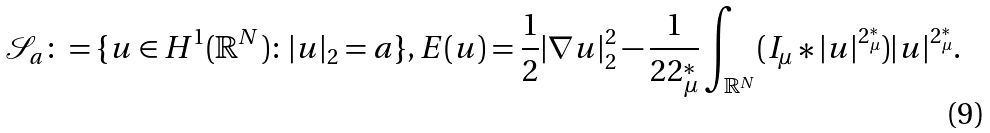Convert formula to latex. <formula><loc_0><loc_0><loc_500><loc_500>\mathcal { S } _ { a } \colon = \{ u \in H ^ { 1 } ( \mathbb { R } ^ { N } ) \colon | u | _ { 2 } = a \} , E ( u ) = \frac { 1 } { 2 } | \nabla u | ^ { 2 } _ { 2 } - \frac { 1 } { 2 2 ^ { * } _ { \mu } } \int _ { \mathbb { R } ^ { N } } ( I _ { \mu } \ast | u | ^ { 2 ^ { * } _ { \mu } } ) | u | ^ { 2 ^ { * } _ { \mu } } .</formula> 